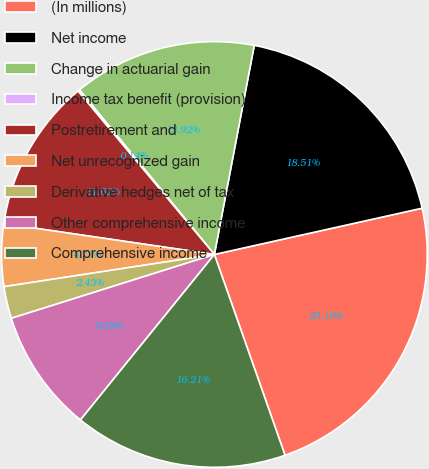<chart> <loc_0><loc_0><loc_500><loc_500><pie_chart><fcel>(In millions)<fcel>Net income<fcel>Change in actuarial gain<fcel>Income tax benefit (provision)<fcel>Postretirement and<fcel>Net unrecognized gain<fcel>Derivative hedges net of tax<fcel>Other comprehensive income<fcel>Comprehensive income<nl><fcel>23.1%<fcel>18.51%<fcel>13.92%<fcel>0.14%<fcel>11.62%<fcel>4.73%<fcel>2.43%<fcel>9.32%<fcel>16.21%<nl></chart> 